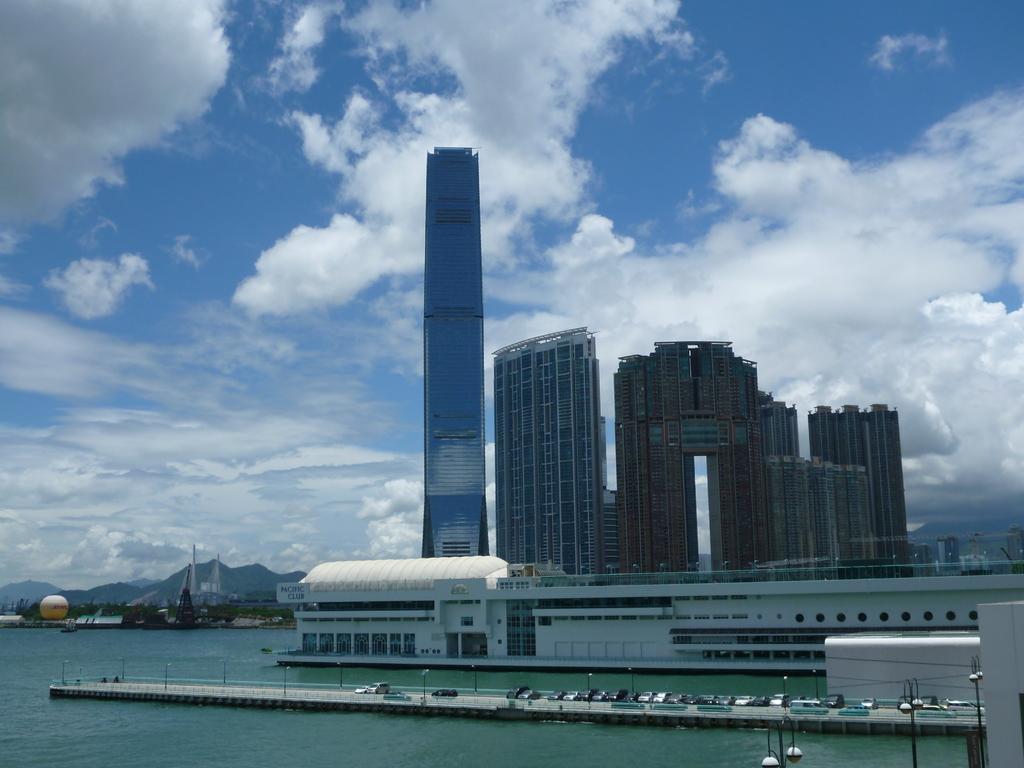How would you summarize this image in a sentence or two? In this picture, there are buildings beside the water. At the bottom, there is a bridge with vehicles. In the background there are hills, buildings and a sky with clouds. 